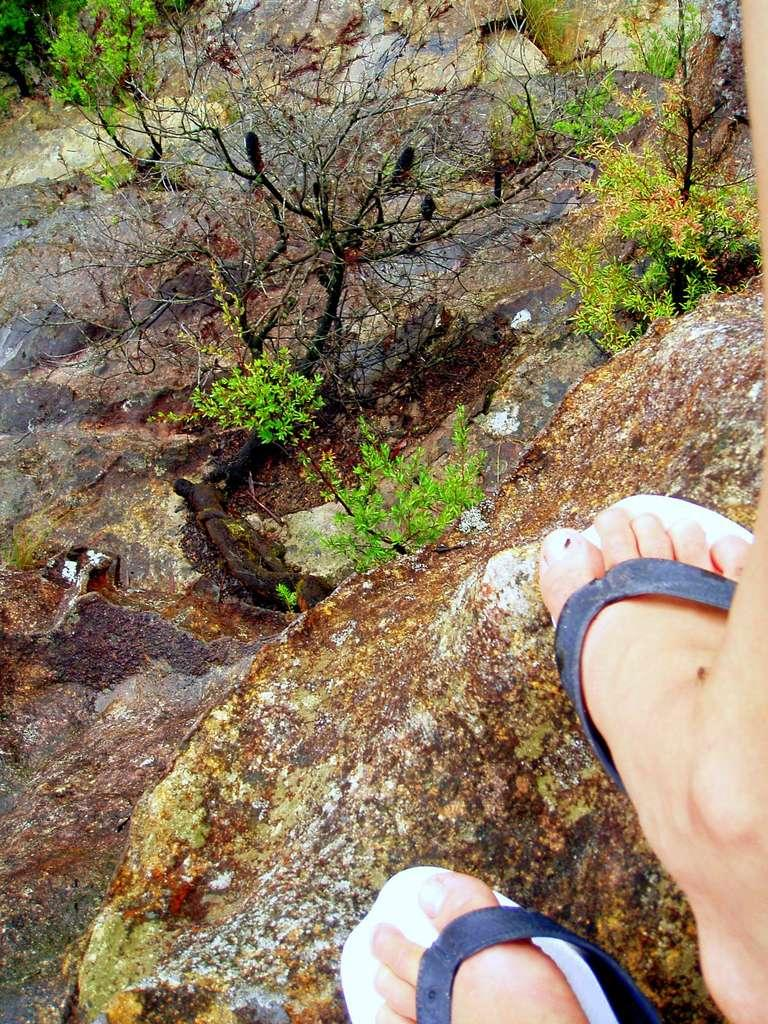What body part and footwear can be seen in the bottom right side of the image? There is a person's legs and footwear visible in the bottom right side of the image. What type of surface is present in the image? There is a rock surface in the image. What type of vegetation can be seen in the image? There are plants in the image. How many tomatoes are on the person's nose in the image? There are no tomatoes or person's nose present in the image. What type of furniture can be seen in the bedroom in the image? There is no bedroom or furniture present in the image. 